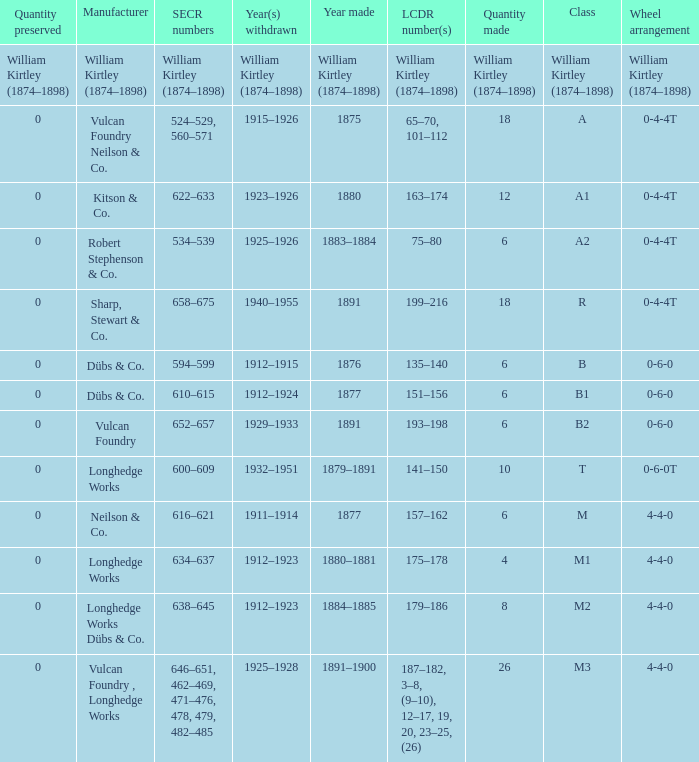Which class was made in 1880? A1. 